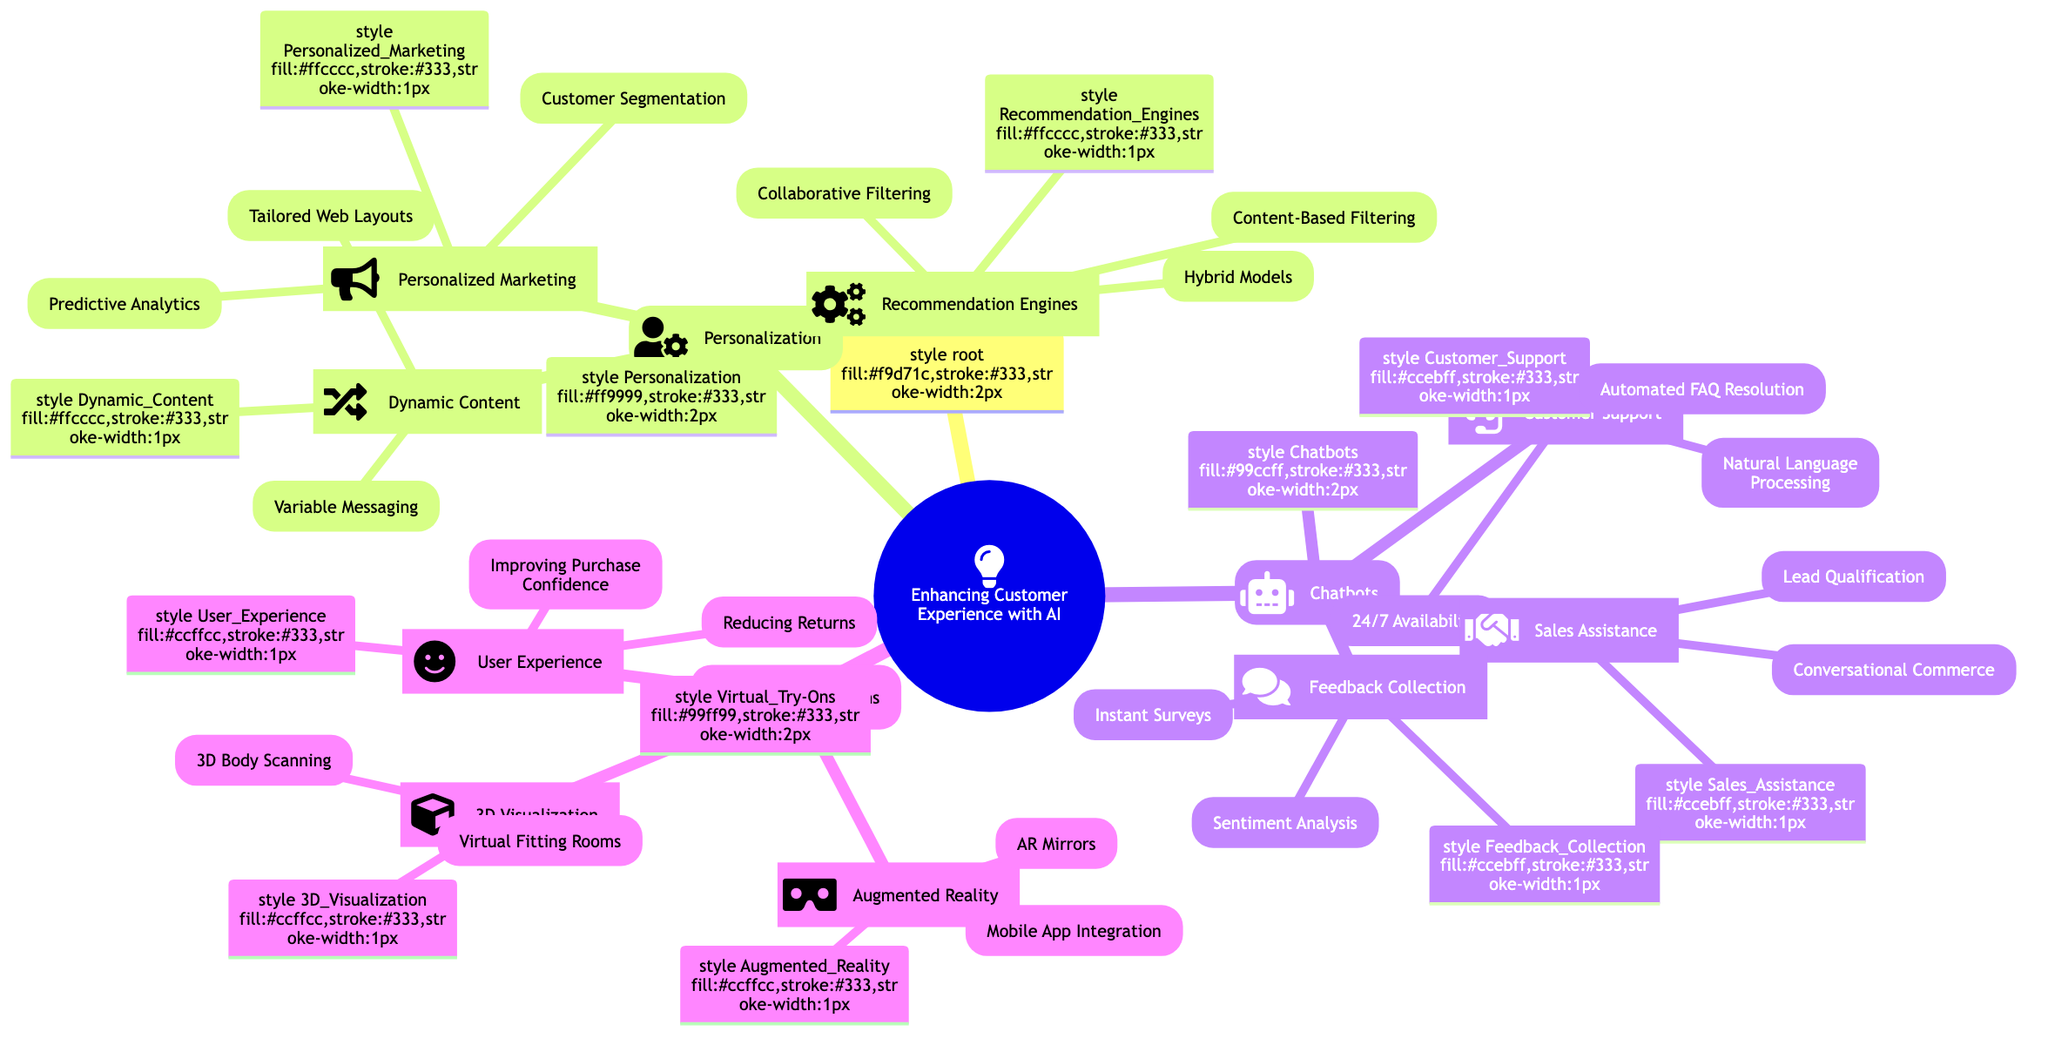What are the three main categories of enhancing customer experience through AI? The diagram has three primary branches emanating from the central node "Enhancing Customer Experience through AI," which are "Personalization," "Chatbots," and "Virtual Try-Ons."
Answer: Personalization, Chatbots, Virtual Try-Ons Which technology is used for predictive analytics in personalized marketing? The "Personalized Marketing" node includes "Predictive Analytics," which is specifically associated with "Google AdWords" as an example in the diagram.
Answer: Google AdWords How many subcategories are under chatbots? The "Chatbots" node branches into three subcategories, which are "Customer Support," "Sales Assistance," and "Feedback Collection." Counting these gives a total of three subcategories.
Answer: 3 What is an example of collaborative filtering in recommendation engines? Under the "Recommendation Engines" section, the "Collaborative Filtering" node has "Amazon's Product Recommendations" listed as an example of this technology.
Answer: Amazon's Product Recommendations Which augmented reality technology is used for mobile app integration? The "Augmented Reality" node has "Mobile App Integration," which is associated with "Sephora Virtual Artist" as the example given in the diagram.
Answer: Sephora Virtual Artist What is the relationship between dynamic content and tailored web layouts? The "Dynamic Content" node contains "Tailored Web Layouts" as one of its branches, indicating that tailored web layouts fall under the broader category of dynamic content.
Answer: Dynamic Content Which chatbot feature provides automated FAQ resolution? Within the "Customer Support" section of "Chatbots," "Automated FAQ Resolution" is explicitly mentioned as a feature, highlighting its automation aspect in responding to frequently asked questions.
Answer: Automated FAQ Resolution What impact does reducing returns have on user experience? The "User Experience" branch includes "Reducing Returns," indicating that this factor positively contributes to enhancing user experience by minimizing the inconvenience of returning items.
Answer: Reducing Returns 